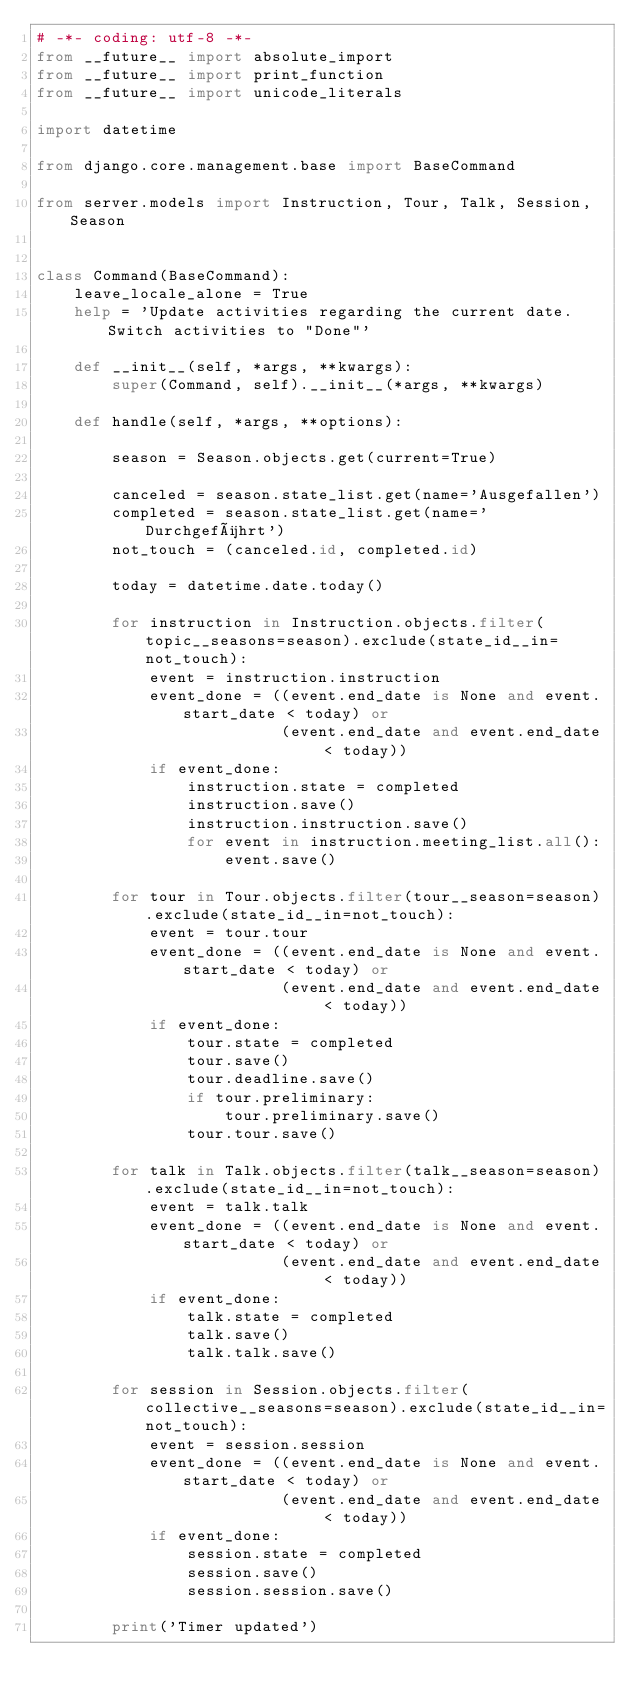<code> <loc_0><loc_0><loc_500><loc_500><_Python_># -*- coding: utf-8 -*-
from __future__ import absolute_import
from __future__ import print_function
from __future__ import unicode_literals

import datetime

from django.core.management.base import BaseCommand

from server.models import Instruction, Tour, Talk, Session, Season


class Command(BaseCommand):
    leave_locale_alone = True
    help = 'Update activities regarding the current date. Switch activities to "Done"'

    def __init__(self, *args, **kwargs):
        super(Command, self).__init__(*args, **kwargs)

    def handle(self, *args, **options):

        season = Season.objects.get(current=True)

        canceled = season.state_list.get(name='Ausgefallen')
        completed = season.state_list.get(name='Durchgeführt')
        not_touch = (canceled.id, completed.id)

        today = datetime.date.today()

        for instruction in Instruction.objects.filter(topic__seasons=season).exclude(state_id__in=not_touch):
            event = instruction.instruction
            event_done = ((event.end_date is None and event.start_date < today) or
                          (event.end_date and event.end_date < today))
            if event_done:
                instruction.state = completed
                instruction.save()
                instruction.instruction.save()
                for event in instruction.meeting_list.all():
                    event.save()

        for tour in Tour.objects.filter(tour__season=season).exclude(state_id__in=not_touch):
            event = tour.tour
            event_done = ((event.end_date is None and event.start_date < today) or
                          (event.end_date and event.end_date < today))
            if event_done:
                tour.state = completed
                tour.save()
                tour.deadline.save()
                if tour.preliminary:
                    tour.preliminary.save()
                tour.tour.save()

        for talk in Talk.objects.filter(talk__season=season).exclude(state_id__in=not_touch):
            event = talk.talk
            event_done = ((event.end_date is None and event.start_date < today) or
                          (event.end_date and event.end_date < today))
            if event_done:
                talk.state = completed
                talk.save()
                talk.talk.save()

        for session in Session.objects.filter(collective__seasons=season).exclude(state_id__in=not_touch):
            event = session.session
            event_done = ((event.end_date is None and event.start_date < today) or
                          (event.end_date and event.end_date < today))
            if event_done:
                session.state = completed
                session.save()
                session.session.save()

        print('Timer updated')
</code> 